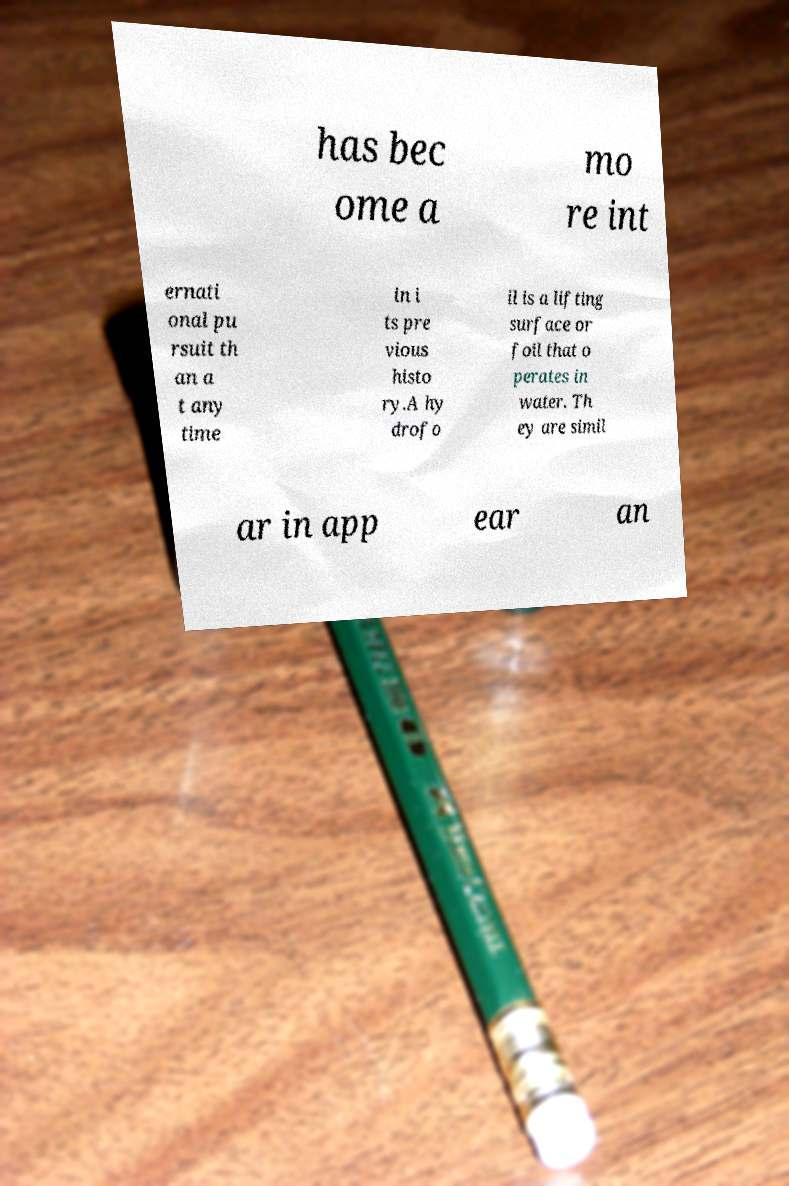For documentation purposes, I need the text within this image transcribed. Could you provide that? has bec ome a mo re int ernati onal pu rsuit th an a t any time in i ts pre vious histo ry.A hy drofo il is a lifting surface or foil that o perates in water. Th ey are simil ar in app ear an 